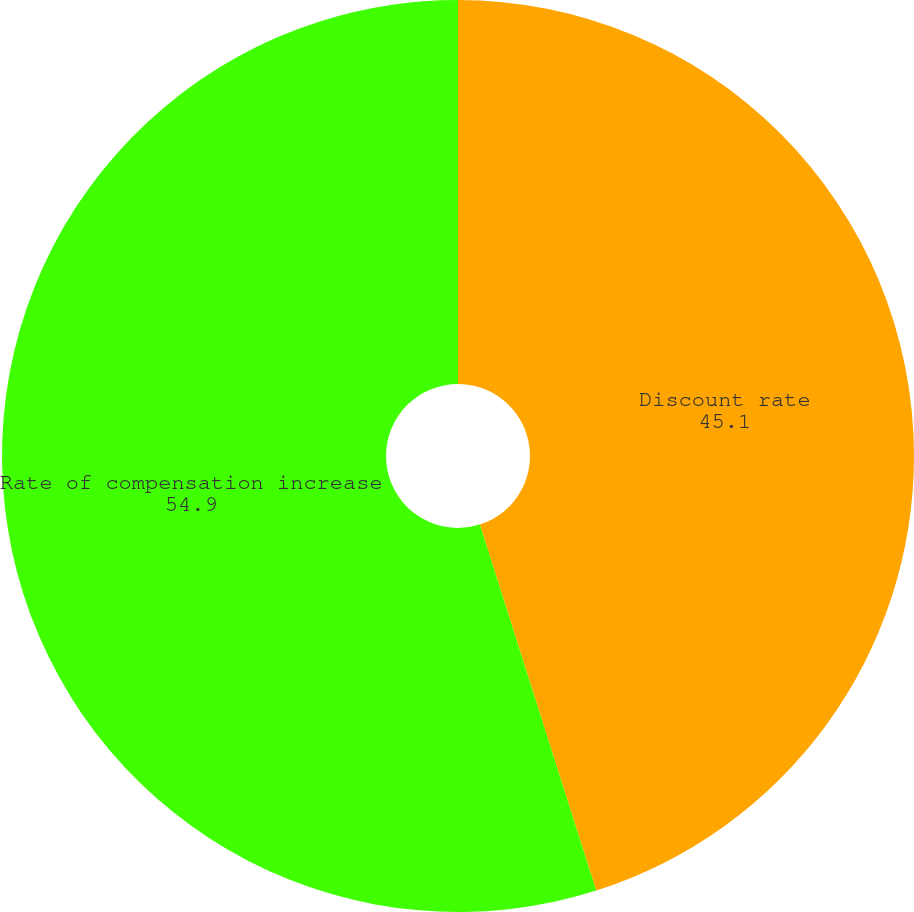Convert chart. <chart><loc_0><loc_0><loc_500><loc_500><pie_chart><fcel>Discount rate<fcel>Rate of compensation increase<nl><fcel>45.1%<fcel>54.9%<nl></chart> 